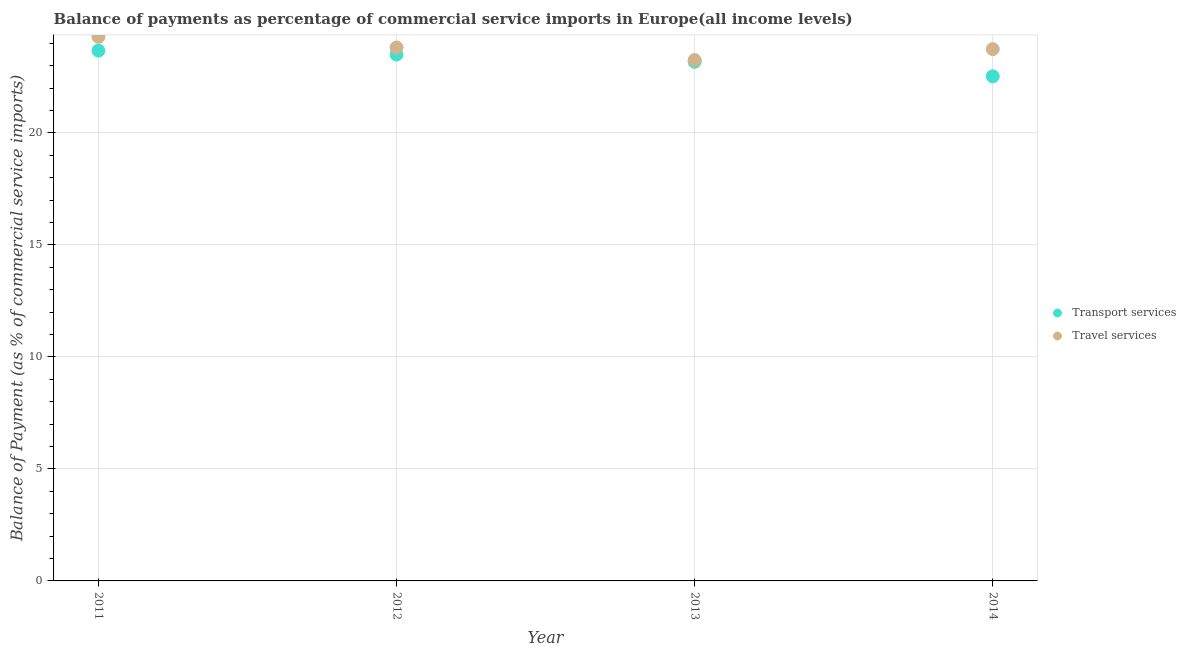How many different coloured dotlines are there?
Your answer should be very brief. 2. Is the number of dotlines equal to the number of legend labels?
Offer a very short reply. Yes. What is the balance of payments of travel services in 2011?
Give a very brief answer. 24.29. Across all years, what is the maximum balance of payments of travel services?
Your response must be concise. 24.29. Across all years, what is the minimum balance of payments of travel services?
Your answer should be very brief. 23.26. In which year was the balance of payments of travel services maximum?
Your answer should be compact. 2011. What is the total balance of payments of transport services in the graph?
Your answer should be compact. 92.89. What is the difference between the balance of payments of transport services in 2012 and that in 2013?
Your answer should be very brief. 0.32. What is the difference between the balance of payments of travel services in 2013 and the balance of payments of transport services in 2012?
Make the answer very short. -0.25. What is the average balance of payments of transport services per year?
Provide a short and direct response. 23.22. In the year 2014, what is the difference between the balance of payments of travel services and balance of payments of transport services?
Make the answer very short. 1.21. What is the ratio of the balance of payments of travel services in 2011 to that in 2012?
Provide a short and direct response. 1.02. What is the difference between the highest and the second highest balance of payments of transport services?
Make the answer very short. 0.17. What is the difference between the highest and the lowest balance of payments of travel services?
Offer a terse response. 1.04. How many dotlines are there?
Make the answer very short. 2. What is the difference between two consecutive major ticks on the Y-axis?
Your answer should be very brief. 5. Are the values on the major ticks of Y-axis written in scientific E-notation?
Provide a succinct answer. No. Does the graph contain grids?
Make the answer very short. Yes. How are the legend labels stacked?
Provide a succinct answer. Vertical. What is the title of the graph?
Make the answer very short. Balance of payments as percentage of commercial service imports in Europe(all income levels). What is the label or title of the X-axis?
Offer a very short reply. Year. What is the label or title of the Y-axis?
Make the answer very short. Balance of Payment (as % of commercial service imports). What is the Balance of Payment (as % of commercial service imports) in Transport services in 2011?
Your answer should be very brief. 23.68. What is the Balance of Payment (as % of commercial service imports) of Travel services in 2011?
Offer a terse response. 24.29. What is the Balance of Payment (as % of commercial service imports) of Transport services in 2012?
Your response must be concise. 23.5. What is the Balance of Payment (as % of commercial service imports) of Travel services in 2012?
Your response must be concise. 23.81. What is the Balance of Payment (as % of commercial service imports) in Transport services in 2013?
Your response must be concise. 23.18. What is the Balance of Payment (as % of commercial service imports) of Travel services in 2013?
Make the answer very short. 23.26. What is the Balance of Payment (as % of commercial service imports) in Transport services in 2014?
Make the answer very short. 22.53. What is the Balance of Payment (as % of commercial service imports) of Travel services in 2014?
Your answer should be very brief. 23.74. Across all years, what is the maximum Balance of Payment (as % of commercial service imports) of Transport services?
Offer a very short reply. 23.68. Across all years, what is the maximum Balance of Payment (as % of commercial service imports) in Travel services?
Offer a terse response. 24.29. Across all years, what is the minimum Balance of Payment (as % of commercial service imports) in Transport services?
Offer a terse response. 22.53. Across all years, what is the minimum Balance of Payment (as % of commercial service imports) of Travel services?
Provide a short and direct response. 23.26. What is the total Balance of Payment (as % of commercial service imports) in Transport services in the graph?
Make the answer very short. 92.89. What is the total Balance of Payment (as % of commercial service imports) of Travel services in the graph?
Your answer should be compact. 95.11. What is the difference between the Balance of Payment (as % of commercial service imports) of Transport services in 2011 and that in 2012?
Your response must be concise. 0.17. What is the difference between the Balance of Payment (as % of commercial service imports) of Travel services in 2011 and that in 2012?
Give a very brief answer. 0.48. What is the difference between the Balance of Payment (as % of commercial service imports) of Transport services in 2011 and that in 2013?
Keep it short and to the point. 0.5. What is the difference between the Balance of Payment (as % of commercial service imports) in Travel services in 2011 and that in 2013?
Your answer should be very brief. 1.04. What is the difference between the Balance of Payment (as % of commercial service imports) of Transport services in 2011 and that in 2014?
Ensure brevity in your answer.  1.15. What is the difference between the Balance of Payment (as % of commercial service imports) of Travel services in 2011 and that in 2014?
Give a very brief answer. 0.55. What is the difference between the Balance of Payment (as % of commercial service imports) in Transport services in 2012 and that in 2013?
Give a very brief answer. 0.32. What is the difference between the Balance of Payment (as % of commercial service imports) of Travel services in 2012 and that in 2013?
Ensure brevity in your answer.  0.56. What is the difference between the Balance of Payment (as % of commercial service imports) of Transport services in 2012 and that in 2014?
Keep it short and to the point. 0.97. What is the difference between the Balance of Payment (as % of commercial service imports) in Travel services in 2012 and that in 2014?
Make the answer very short. 0.07. What is the difference between the Balance of Payment (as % of commercial service imports) of Transport services in 2013 and that in 2014?
Your response must be concise. 0.65. What is the difference between the Balance of Payment (as % of commercial service imports) in Travel services in 2013 and that in 2014?
Give a very brief answer. -0.49. What is the difference between the Balance of Payment (as % of commercial service imports) in Transport services in 2011 and the Balance of Payment (as % of commercial service imports) in Travel services in 2012?
Provide a succinct answer. -0.14. What is the difference between the Balance of Payment (as % of commercial service imports) in Transport services in 2011 and the Balance of Payment (as % of commercial service imports) in Travel services in 2013?
Your answer should be very brief. 0.42. What is the difference between the Balance of Payment (as % of commercial service imports) in Transport services in 2011 and the Balance of Payment (as % of commercial service imports) in Travel services in 2014?
Provide a short and direct response. -0.07. What is the difference between the Balance of Payment (as % of commercial service imports) of Transport services in 2012 and the Balance of Payment (as % of commercial service imports) of Travel services in 2013?
Offer a very short reply. 0.25. What is the difference between the Balance of Payment (as % of commercial service imports) in Transport services in 2012 and the Balance of Payment (as % of commercial service imports) in Travel services in 2014?
Offer a very short reply. -0.24. What is the difference between the Balance of Payment (as % of commercial service imports) of Transport services in 2013 and the Balance of Payment (as % of commercial service imports) of Travel services in 2014?
Keep it short and to the point. -0.57. What is the average Balance of Payment (as % of commercial service imports) in Transport services per year?
Offer a terse response. 23.22. What is the average Balance of Payment (as % of commercial service imports) of Travel services per year?
Keep it short and to the point. 23.78. In the year 2011, what is the difference between the Balance of Payment (as % of commercial service imports) of Transport services and Balance of Payment (as % of commercial service imports) of Travel services?
Provide a short and direct response. -0.62. In the year 2012, what is the difference between the Balance of Payment (as % of commercial service imports) in Transport services and Balance of Payment (as % of commercial service imports) in Travel services?
Your answer should be very brief. -0.31. In the year 2013, what is the difference between the Balance of Payment (as % of commercial service imports) of Transport services and Balance of Payment (as % of commercial service imports) of Travel services?
Your answer should be very brief. -0.08. In the year 2014, what is the difference between the Balance of Payment (as % of commercial service imports) in Transport services and Balance of Payment (as % of commercial service imports) in Travel services?
Give a very brief answer. -1.21. What is the ratio of the Balance of Payment (as % of commercial service imports) in Transport services in 2011 to that in 2012?
Offer a terse response. 1.01. What is the ratio of the Balance of Payment (as % of commercial service imports) in Travel services in 2011 to that in 2012?
Keep it short and to the point. 1.02. What is the ratio of the Balance of Payment (as % of commercial service imports) of Transport services in 2011 to that in 2013?
Provide a succinct answer. 1.02. What is the ratio of the Balance of Payment (as % of commercial service imports) of Travel services in 2011 to that in 2013?
Keep it short and to the point. 1.04. What is the ratio of the Balance of Payment (as % of commercial service imports) in Transport services in 2011 to that in 2014?
Provide a short and direct response. 1.05. What is the ratio of the Balance of Payment (as % of commercial service imports) of Travel services in 2011 to that in 2014?
Your answer should be compact. 1.02. What is the ratio of the Balance of Payment (as % of commercial service imports) of Transport services in 2012 to that in 2013?
Your response must be concise. 1.01. What is the ratio of the Balance of Payment (as % of commercial service imports) in Travel services in 2012 to that in 2013?
Offer a very short reply. 1.02. What is the ratio of the Balance of Payment (as % of commercial service imports) of Transport services in 2012 to that in 2014?
Give a very brief answer. 1.04. What is the ratio of the Balance of Payment (as % of commercial service imports) in Travel services in 2012 to that in 2014?
Offer a very short reply. 1. What is the ratio of the Balance of Payment (as % of commercial service imports) in Transport services in 2013 to that in 2014?
Provide a succinct answer. 1.03. What is the ratio of the Balance of Payment (as % of commercial service imports) of Travel services in 2013 to that in 2014?
Offer a terse response. 0.98. What is the difference between the highest and the second highest Balance of Payment (as % of commercial service imports) in Transport services?
Make the answer very short. 0.17. What is the difference between the highest and the second highest Balance of Payment (as % of commercial service imports) in Travel services?
Give a very brief answer. 0.48. What is the difference between the highest and the lowest Balance of Payment (as % of commercial service imports) in Transport services?
Keep it short and to the point. 1.15. What is the difference between the highest and the lowest Balance of Payment (as % of commercial service imports) in Travel services?
Provide a short and direct response. 1.04. 